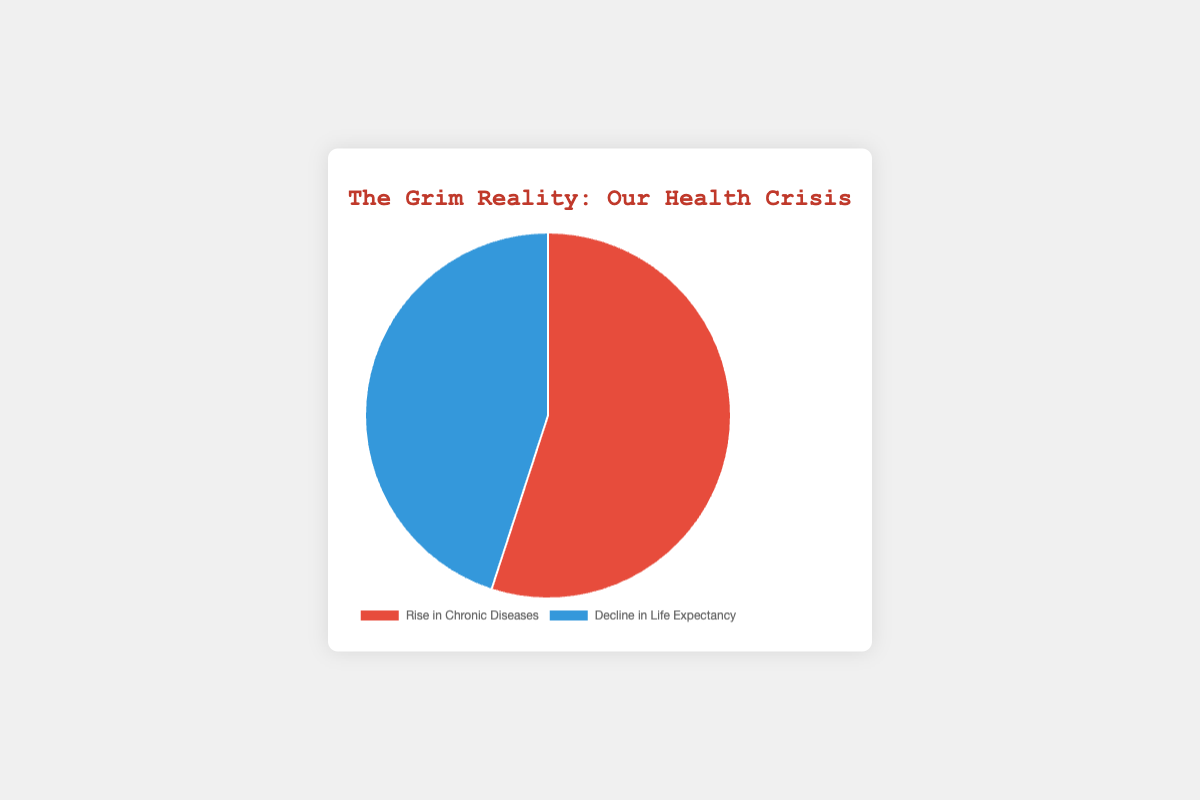What's the percentage of health crises attributed to "Rise in Chronic Diseases"? By referring to the chart, we see that "Rise in Chronic Diseases" accounts for 55% of the health crisis.
Answer: 55% Which category takes up more than half of the total health crisis pie chart? The only category taking up more than half of the pie chart is "Rise in Chronic Diseases" with 55%.
Answer: Rise in Chronic Diseases What is the difference in percentages between "Rise in Chronic Diseases" and "Decline in Life Expectancy"? Subtract the "Decline in Life Expectancy" percentage (45%) from the "Rise in Chronic Diseases" percentage (55%). 55% - 45% = 10%
Answer: 10% How does the slice for "Decline in Life Expectancy" compare in size to the "Rise in Chronic Diseases"? The slice for "Decline in Life Expectancy" is smaller. It accounts for 45%, whereas "Rise in Chronic Diseases" accounts for 55%.
Answer: Smaller If we add the percentages of both categories, what will be the total percentage? Adding 55% (Rise in Chronic Diseases) and 45% (Decline in Life Expectancy) gives us 100%.
Answer: 100% What color represents "Decline in Life Expectancy" in the pie chart? In the chart, "Decline in Life Expectancy" is represented by the blue color.
Answer: Blue Which category is visually more dominant in the pie chart, and by what percentage? "Rise in Chronic Diseases" is visually more dominant, taking up 55% compared to the 45% for "Decline in Life Expectancy".
Answer: Rise in Chronic Diseases by 10% How much smaller is the percentage of "Decline in Life Expectancy" compared to "Rise in Chronic Diseases"? The percentage of "Decline in Life Expectancy" is smaller by 10% compared to the "Rise in Chronic Diseases".
Answer: 10% From a visual perspective, explain the distribution of chronic diseases vs. life expectancy. Visually, the pie chart shows that a larger portion (55%) is attributed to chronic diseases (in red), whereas a smaller portion (45%) is due to the decline in life expectancy (in blue), indicating a slightly higher impact of chronic diseases.
Answer: 55% chronic diseases, 45% life expectancy 